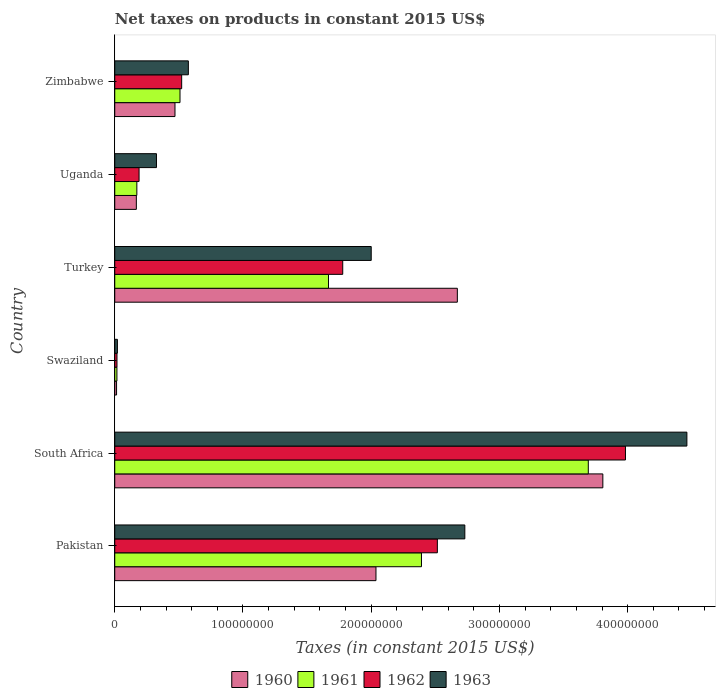How many bars are there on the 2nd tick from the bottom?
Provide a short and direct response. 4. What is the label of the 2nd group of bars from the top?
Provide a succinct answer. Uganda. In how many cases, is the number of bars for a given country not equal to the number of legend labels?
Give a very brief answer. 0. Across all countries, what is the maximum net taxes on products in 1962?
Your response must be concise. 3.98e+08. Across all countries, what is the minimum net taxes on products in 1962?
Offer a very short reply. 1.73e+06. In which country was the net taxes on products in 1960 maximum?
Your answer should be compact. South Africa. In which country was the net taxes on products in 1961 minimum?
Offer a very short reply. Swaziland. What is the total net taxes on products in 1962 in the graph?
Your answer should be very brief. 9.00e+08. What is the difference between the net taxes on products in 1963 in Uganda and that in Zimbabwe?
Your response must be concise. -2.49e+07. What is the difference between the net taxes on products in 1960 in Uganda and the net taxes on products in 1963 in Pakistan?
Your answer should be very brief. -2.56e+08. What is the average net taxes on products in 1963 per country?
Keep it short and to the point. 1.69e+08. What is the difference between the net taxes on products in 1960 and net taxes on products in 1962 in Pakistan?
Provide a succinct answer. -4.79e+07. What is the ratio of the net taxes on products in 1962 in Turkey to that in Zimbabwe?
Give a very brief answer. 3.41. What is the difference between the highest and the second highest net taxes on products in 1963?
Give a very brief answer. 1.73e+08. What is the difference between the highest and the lowest net taxes on products in 1962?
Provide a short and direct response. 3.97e+08. In how many countries, is the net taxes on products in 1962 greater than the average net taxes on products in 1962 taken over all countries?
Keep it short and to the point. 3. Is it the case that in every country, the sum of the net taxes on products in 1960 and net taxes on products in 1963 is greater than the net taxes on products in 1961?
Give a very brief answer. Yes. How many bars are there?
Your response must be concise. 24. How many countries are there in the graph?
Give a very brief answer. 6. What is the difference between two consecutive major ticks on the X-axis?
Ensure brevity in your answer.  1.00e+08. Does the graph contain any zero values?
Offer a terse response. No. Does the graph contain grids?
Give a very brief answer. No. Where does the legend appear in the graph?
Your response must be concise. Bottom center. How many legend labels are there?
Your answer should be very brief. 4. What is the title of the graph?
Your answer should be compact. Net taxes on products in constant 2015 US$. Does "2011" appear as one of the legend labels in the graph?
Make the answer very short. No. What is the label or title of the X-axis?
Keep it short and to the point. Taxes (in constant 2015 US$). What is the label or title of the Y-axis?
Give a very brief answer. Country. What is the Taxes (in constant 2015 US$) in 1960 in Pakistan?
Your response must be concise. 2.04e+08. What is the Taxes (in constant 2015 US$) of 1961 in Pakistan?
Ensure brevity in your answer.  2.39e+08. What is the Taxes (in constant 2015 US$) of 1962 in Pakistan?
Offer a very short reply. 2.52e+08. What is the Taxes (in constant 2015 US$) of 1963 in Pakistan?
Provide a short and direct response. 2.73e+08. What is the Taxes (in constant 2015 US$) of 1960 in South Africa?
Your response must be concise. 3.81e+08. What is the Taxes (in constant 2015 US$) of 1961 in South Africa?
Make the answer very short. 3.69e+08. What is the Taxes (in constant 2015 US$) of 1962 in South Africa?
Give a very brief answer. 3.98e+08. What is the Taxes (in constant 2015 US$) in 1963 in South Africa?
Give a very brief answer. 4.46e+08. What is the Taxes (in constant 2015 US$) in 1960 in Swaziland?
Make the answer very short. 1.40e+06. What is the Taxes (in constant 2015 US$) in 1961 in Swaziland?
Provide a short and direct response. 1.69e+06. What is the Taxes (in constant 2015 US$) of 1962 in Swaziland?
Provide a succinct answer. 1.73e+06. What is the Taxes (in constant 2015 US$) in 1963 in Swaziland?
Give a very brief answer. 2.06e+06. What is the Taxes (in constant 2015 US$) in 1960 in Turkey?
Your answer should be very brief. 2.67e+08. What is the Taxes (in constant 2015 US$) in 1961 in Turkey?
Offer a very short reply. 1.67e+08. What is the Taxes (in constant 2015 US$) in 1962 in Turkey?
Provide a succinct answer. 1.78e+08. What is the Taxes (in constant 2015 US$) in 1963 in Turkey?
Provide a succinct answer. 2.00e+08. What is the Taxes (in constant 2015 US$) of 1960 in Uganda?
Give a very brief answer. 1.68e+07. What is the Taxes (in constant 2015 US$) of 1961 in Uganda?
Your response must be concise. 1.72e+07. What is the Taxes (in constant 2015 US$) of 1962 in Uganda?
Keep it short and to the point. 1.90e+07. What is the Taxes (in constant 2015 US$) in 1963 in Uganda?
Give a very brief answer. 3.25e+07. What is the Taxes (in constant 2015 US$) of 1960 in Zimbabwe?
Your response must be concise. 4.70e+07. What is the Taxes (in constant 2015 US$) in 1961 in Zimbabwe?
Your answer should be very brief. 5.09e+07. What is the Taxes (in constant 2015 US$) of 1962 in Zimbabwe?
Your answer should be compact. 5.22e+07. What is the Taxes (in constant 2015 US$) of 1963 in Zimbabwe?
Your response must be concise. 5.74e+07. Across all countries, what is the maximum Taxes (in constant 2015 US$) in 1960?
Your response must be concise. 3.81e+08. Across all countries, what is the maximum Taxes (in constant 2015 US$) of 1961?
Provide a short and direct response. 3.69e+08. Across all countries, what is the maximum Taxes (in constant 2015 US$) in 1962?
Your response must be concise. 3.98e+08. Across all countries, what is the maximum Taxes (in constant 2015 US$) of 1963?
Ensure brevity in your answer.  4.46e+08. Across all countries, what is the minimum Taxes (in constant 2015 US$) of 1960?
Make the answer very short. 1.40e+06. Across all countries, what is the minimum Taxes (in constant 2015 US$) in 1961?
Offer a terse response. 1.69e+06. Across all countries, what is the minimum Taxes (in constant 2015 US$) in 1962?
Provide a short and direct response. 1.73e+06. Across all countries, what is the minimum Taxes (in constant 2015 US$) of 1963?
Offer a very short reply. 2.06e+06. What is the total Taxes (in constant 2015 US$) in 1960 in the graph?
Give a very brief answer. 9.17e+08. What is the total Taxes (in constant 2015 US$) in 1961 in the graph?
Make the answer very short. 8.45e+08. What is the total Taxes (in constant 2015 US$) in 1962 in the graph?
Offer a very short reply. 9.00e+08. What is the total Taxes (in constant 2015 US$) in 1963 in the graph?
Offer a very short reply. 1.01e+09. What is the difference between the Taxes (in constant 2015 US$) of 1960 in Pakistan and that in South Africa?
Provide a short and direct response. -1.77e+08. What is the difference between the Taxes (in constant 2015 US$) of 1961 in Pakistan and that in South Africa?
Provide a succinct answer. -1.30e+08. What is the difference between the Taxes (in constant 2015 US$) in 1962 in Pakistan and that in South Africa?
Your answer should be compact. -1.47e+08. What is the difference between the Taxes (in constant 2015 US$) of 1963 in Pakistan and that in South Africa?
Keep it short and to the point. -1.73e+08. What is the difference between the Taxes (in constant 2015 US$) in 1960 in Pakistan and that in Swaziland?
Your response must be concise. 2.02e+08. What is the difference between the Taxes (in constant 2015 US$) of 1961 in Pakistan and that in Swaziland?
Offer a terse response. 2.37e+08. What is the difference between the Taxes (in constant 2015 US$) of 1962 in Pakistan and that in Swaziland?
Ensure brevity in your answer.  2.50e+08. What is the difference between the Taxes (in constant 2015 US$) in 1963 in Pakistan and that in Swaziland?
Your answer should be compact. 2.71e+08. What is the difference between the Taxes (in constant 2015 US$) in 1960 in Pakistan and that in Turkey?
Offer a terse response. -6.35e+07. What is the difference between the Taxes (in constant 2015 US$) in 1961 in Pakistan and that in Turkey?
Your answer should be very brief. 7.25e+07. What is the difference between the Taxes (in constant 2015 US$) of 1962 in Pakistan and that in Turkey?
Give a very brief answer. 7.38e+07. What is the difference between the Taxes (in constant 2015 US$) of 1963 in Pakistan and that in Turkey?
Make the answer very short. 7.30e+07. What is the difference between the Taxes (in constant 2015 US$) of 1960 in Pakistan and that in Uganda?
Offer a very short reply. 1.87e+08. What is the difference between the Taxes (in constant 2015 US$) of 1961 in Pakistan and that in Uganda?
Keep it short and to the point. 2.22e+08. What is the difference between the Taxes (in constant 2015 US$) in 1962 in Pakistan and that in Uganda?
Your response must be concise. 2.33e+08. What is the difference between the Taxes (in constant 2015 US$) of 1963 in Pakistan and that in Uganda?
Provide a short and direct response. 2.40e+08. What is the difference between the Taxes (in constant 2015 US$) in 1960 in Pakistan and that in Zimbabwe?
Offer a terse response. 1.57e+08. What is the difference between the Taxes (in constant 2015 US$) in 1961 in Pakistan and that in Zimbabwe?
Provide a succinct answer. 1.88e+08. What is the difference between the Taxes (in constant 2015 US$) of 1962 in Pakistan and that in Zimbabwe?
Ensure brevity in your answer.  1.99e+08. What is the difference between the Taxes (in constant 2015 US$) of 1963 in Pakistan and that in Zimbabwe?
Your response must be concise. 2.16e+08. What is the difference between the Taxes (in constant 2015 US$) of 1960 in South Africa and that in Swaziland?
Give a very brief answer. 3.79e+08. What is the difference between the Taxes (in constant 2015 US$) in 1961 in South Africa and that in Swaziland?
Provide a succinct answer. 3.68e+08. What is the difference between the Taxes (in constant 2015 US$) of 1962 in South Africa and that in Swaziland?
Offer a very short reply. 3.97e+08. What is the difference between the Taxes (in constant 2015 US$) of 1963 in South Africa and that in Swaziland?
Your answer should be compact. 4.44e+08. What is the difference between the Taxes (in constant 2015 US$) in 1960 in South Africa and that in Turkey?
Offer a terse response. 1.13e+08. What is the difference between the Taxes (in constant 2015 US$) of 1961 in South Africa and that in Turkey?
Offer a terse response. 2.03e+08. What is the difference between the Taxes (in constant 2015 US$) of 1962 in South Africa and that in Turkey?
Offer a terse response. 2.20e+08. What is the difference between the Taxes (in constant 2015 US$) in 1963 in South Africa and that in Turkey?
Your answer should be compact. 2.46e+08. What is the difference between the Taxes (in constant 2015 US$) in 1960 in South Africa and that in Uganda?
Make the answer very short. 3.64e+08. What is the difference between the Taxes (in constant 2015 US$) of 1961 in South Africa and that in Uganda?
Give a very brief answer. 3.52e+08. What is the difference between the Taxes (in constant 2015 US$) of 1962 in South Africa and that in Uganda?
Provide a short and direct response. 3.79e+08. What is the difference between the Taxes (in constant 2015 US$) of 1963 in South Africa and that in Uganda?
Make the answer very short. 4.14e+08. What is the difference between the Taxes (in constant 2015 US$) of 1960 in South Africa and that in Zimbabwe?
Your response must be concise. 3.34e+08. What is the difference between the Taxes (in constant 2015 US$) of 1961 in South Africa and that in Zimbabwe?
Provide a short and direct response. 3.18e+08. What is the difference between the Taxes (in constant 2015 US$) in 1962 in South Africa and that in Zimbabwe?
Your answer should be very brief. 3.46e+08. What is the difference between the Taxes (in constant 2015 US$) of 1963 in South Africa and that in Zimbabwe?
Your response must be concise. 3.89e+08. What is the difference between the Taxes (in constant 2015 US$) in 1960 in Swaziland and that in Turkey?
Your answer should be compact. -2.66e+08. What is the difference between the Taxes (in constant 2015 US$) of 1961 in Swaziland and that in Turkey?
Provide a succinct answer. -1.65e+08. What is the difference between the Taxes (in constant 2015 US$) of 1962 in Swaziland and that in Turkey?
Your answer should be compact. -1.76e+08. What is the difference between the Taxes (in constant 2015 US$) in 1963 in Swaziland and that in Turkey?
Ensure brevity in your answer.  -1.98e+08. What is the difference between the Taxes (in constant 2015 US$) of 1960 in Swaziland and that in Uganda?
Your answer should be compact. -1.54e+07. What is the difference between the Taxes (in constant 2015 US$) of 1961 in Swaziland and that in Uganda?
Make the answer very short. -1.55e+07. What is the difference between the Taxes (in constant 2015 US$) in 1962 in Swaziland and that in Uganda?
Provide a short and direct response. -1.72e+07. What is the difference between the Taxes (in constant 2015 US$) of 1963 in Swaziland and that in Uganda?
Give a very brief answer. -3.05e+07. What is the difference between the Taxes (in constant 2015 US$) of 1960 in Swaziland and that in Zimbabwe?
Make the answer very short. -4.56e+07. What is the difference between the Taxes (in constant 2015 US$) in 1961 in Swaziland and that in Zimbabwe?
Your answer should be very brief. -4.92e+07. What is the difference between the Taxes (in constant 2015 US$) in 1962 in Swaziland and that in Zimbabwe?
Provide a short and direct response. -5.05e+07. What is the difference between the Taxes (in constant 2015 US$) in 1963 in Swaziland and that in Zimbabwe?
Keep it short and to the point. -5.53e+07. What is the difference between the Taxes (in constant 2015 US$) of 1960 in Turkey and that in Uganda?
Ensure brevity in your answer.  2.50e+08. What is the difference between the Taxes (in constant 2015 US$) in 1961 in Turkey and that in Uganda?
Make the answer very short. 1.49e+08. What is the difference between the Taxes (in constant 2015 US$) in 1962 in Turkey and that in Uganda?
Keep it short and to the point. 1.59e+08. What is the difference between the Taxes (in constant 2015 US$) of 1963 in Turkey and that in Uganda?
Give a very brief answer. 1.67e+08. What is the difference between the Taxes (in constant 2015 US$) in 1960 in Turkey and that in Zimbabwe?
Offer a very short reply. 2.20e+08. What is the difference between the Taxes (in constant 2015 US$) of 1961 in Turkey and that in Zimbabwe?
Provide a succinct answer. 1.16e+08. What is the difference between the Taxes (in constant 2015 US$) of 1962 in Turkey and that in Zimbabwe?
Give a very brief answer. 1.26e+08. What is the difference between the Taxes (in constant 2015 US$) of 1963 in Turkey and that in Zimbabwe?
Give a very brief answer. 1.43e+08. What is the difference between the Taxes (in constant 2015 US$) of 1960 in Uganda and that in Zimbabwe?
Ensure brevity in your answer.  -3.01e+07. What is the difference between the Taxes (in constant 2015 US$) in 1961 in Uganda and that in Zimbabwe?
Your answer should be very brief. -3.37e+07. What is the difference between the Taxes (in constant 2015 US$) in 1962 in Uganda and that in Zimbabwe?
Provide a short and direct response. -3.32e+07. What is the difference between the Taxes (in constant 2015 US$) in 1963 in Uganda and that in Zimbabwe?
Your response must be concise. -2.49e+07. What is the difference between the Taxes (in constant 2015 US$) in 1960 in Pakistan and the Taxes (in constant 2015 US$) in 1961 in South Africa?
Ensure brevity in your answer.  -1.66e+08. What is the difference between the Taxes (in constant 2015 US$) of 1960 in Pakistan and the Taxes (in constant 2015 US$) of 1962 in South Africa?
Ensure brevity in your answer.  -1.95e+08. What is the difference between the Taxes (in constant 2015 US$) of 1960 in Pakistan and the Taxes (in constant 2015 US$) of 1963 in South Africa?
Provide a short and direct response. -2.42e+08. What is the difference between the Taxes (in constant 2015 US$) of 1961 in Pakistan and the Taxes (in constant 2015 US$) of 1962 in South Africa?
Your answer should be very brief. -1.59e+08. What is the difference between the Taxes (in constant 2015 US$) in 1961 in Pakistan and the Taxes (in constant 2015 US$) in 1963 in South Africa?
Your answer should be very brief. -2.07e+08. What is the difference between the Taxes (in constant 2015 US$) in 1962 in Pakistan and the Taxes (in constant 2015 US$) in 1963 in South Africa?
Provide a short and direct response. -1.95e+08. What is the difference between the Taxes (in constant 2015 US$) in 1960 in Pakistan and the Taxes (in constant 2015 US$) in 1961 in Swaziland?
Provide a succinct answer. 2.02e+08. What is the difference between the Taxes (in constant 2015 US$) in 1960 in Pakistan and the Taxes (in constant 2015 US$) in 1962 in Swaziland?
Your answer should be very brief. 2.02e+08. What is the difference between the Taxes (in constant 2015 US$) of 1960 in Pakistan and the Taxes (in constant 2015 US$) of 1963 in Swaziland?
Your response must be concise. 2.02e+08. What is the difference between the Taxes (in constant 2015 US$) of 1961 in Pakistan and the Taxes (in constant 2015 US$) of 1962 in Swaziland?
Keep it short and to the point. 2.37e+08. What is the difference between the Taxes (in constant 2015 US$) in 1961 in Pakistan and the Taxes (in constant 2015 US$) in 1963 in Swaziland?
Ensure brevity in your answer.  2.37e+08. What is the difference between the Taxes (in constant 2015 US$) in 1962 in Pakistan and the Taxes (in constant 2015 US$) in 1963 in Swaziland?
Provide a succinct answer. 2.50e+08. What is the difference between the Taxes (in constant 2015 US$) in 1960 in Pakistan and the Taxes (in constant 2015 US$) in 1961 in Turkey?
Provide a short and direct response. 3.70e+07. What is the difference between the Taxes (in constant 2015 US$) in 1960 in Pakistan and the Taxes (in constant 2015 US$) in 1962 in Turkey?
Your answer should be very brief. 2.59e+07. What is the difference between the Taxes (in constant 2015 US$) in 1960 in Pakistan and the Taxes (in constant 2015 US$) in 1963 in Turkey?
Offer a terse response. 3.70e+06. What is the difference between the Taxes (in constant 2015 US$) in 1961 in Pakistan and the Taxes (in constant 2015 US$) in 1962 in Turkey?
Your answer should be very brief. 6.14e+07. What is the difference between the Taxes (in constant 2015 US$) in 1961 in Pakistan and the Taxes (in constant 2015 US$) in 1963 in Turkey?
Your answer should be compact. 3.92e+07. What is the difference between the Taxes (in constant 2015 US$) in 1962 in Pakistan and the Taxes (in constant 2015 US$) in 1963 in Turkey?
Your answer should be compact. 5.16e+07. What is the difference between the Taxes (in constant 2015 US$) of 1960 in Pakistan and the Taxes (in constant 2015 US$) of 1961 in Uganda?
Your answer should be compact. 1.86e+08. What is the difference between the Taxes (in constant 2015 US$) in 1960 in Pakistan and the Taxes (in constant 2015 US$) in 1962 in Uganda?
Your answer should be compact. 1.85e+08. What is the difference between the Taxes (in constant 2015 US$) of 1960 in Pakistan and the Taxes (in constant 2015 US$) of 1963 in Uganda?
Your answer should be very brief. 1.71e+08. What is the difference between the Taxes (in constant 2015 US$) in 1961 in Pakistan and the Taxes (in constant 2015 US$) in 1962 in Uganda?
Offer a very short reply. 2.20e+08. What is the difference between the Taxes (in constant 2015 US$) of 1961 in Pakistan and the Taxes (in constant 2015 US$) of 1963 in Uganda?
Provide a succinct answer. 2.07e+08. What is the difference between the Taxes (in constant 2015 US$) in 1962 in Pakistan and the Taxes (in constant 2015 US$) in 1963 in Uganda?
Offer a terse response. 2.19e+08. What is the difference between the Taxes (in constant 2015 US$) in 1960 in Pakistan and the Taxes (in constant 2015 US$) in 1961 in Zimbabwe?
Ensure brevity in your answer.  1.53e+08. What is the difference between the Taxes (in constant 2015 US$) in 1960 in Pakistan and the Taxes (in constant 2015 US$) in 1962 in Zimbabwe?
Make the answer very short. 1.52e+08. What is the difference between the Taxes (in constant 2015 US$) of 1960 in Pakistan and the Taxes (in constant 2015 US$) of 1963 in Zimbabwe?
Keep it short and to the point. 1.46e+08. What is the difference between the Taxes (in constant 2015 US$) in 1961 in Pakistan and the Taxes (in constant 2015 US$) in 1962 in Zimbabwe?
Make the answer very short. 1.87e+08. What is the difference between the Taxes (in constant 2015 US$) in 1961 in Pakistan and the Taxes (in constant 2015 US$) in 1963 in Zimbabwe?
Your response must be concise. 1.82e+08. What is the difference between the Taxes (in constant 2015 US$) of 1962 in Pakistan and the Taxes (in constant 2015 US$) of 1963 in Zimbabwe?
Your answer should be compact. 1.94e+08. What is the difference between the Taxes (in constant 2015 US$) of 1960 in South Africa and the Taxes (in constant 2015 US$) of 1961 in Swaziland?
Give a very brief answer. 3.79e+08. What is the difference between the Taxes (in constant 2015 US$) of 1960 in South Africa and the Taxes (in constant 2015 US$) of 1962 in Swaziland?
Keep it short and to the point. 3.79e+08. What is the difference between the Taxes (in constant 2015 US$) in 1960 in South Africa and the Taxes (in constant 2015 US$) in 1963 in Swaziland?
Provide a succinct answer. 3.79e+08. What is the difference between the Taxes (in constant 2015 US$) of 1961 in South Africa and the Taxes (in constant 2015 US$) of 1962 in Swaziland?
Keep it short and to the point. 3.68e+08. What is the difference between the Taxes (in constant 2015 US$) of 1961 in South Africa and the Taxes (in constant 2015 US$) of 1963 in Swaziland?
Your answer should be very brief. 3.67e+08. What is the difference between the Taxes (in constant 2015 US$) in 1962 in South Africa and the Taxes (in constant 2015 US$) in 1963 in Swaziland?
Make the answer very short. 3.96e+08. What is the difference between the Taxes (in constant 2015 US$) of 1960 in South Africa and the Taxes (in constant 2015 US$) of 1961 in Turkey?
Your answer should be very brief. 2.14e+08. What is the difference between the Taxes (in constant 2015 US$) of 1960 in South Africa and the Taxes (in constant 2015 US$) of 1962 in Turkey?
Give a very brief answer. 2.03e+08. What is the difference between the Taxes (in constant 2015 US$) in 1960 in South Africa and the Taxes (in constant 2015 US$) in 1963 in Turkey?
Give a very brief answer. 1.81e+08. What is the difference between the Taxes (in constant 2015 US$) in 1961 in South Africa and the Taxes (in constant 2015 US$) in 1962 in Turkey?
Your answer should be compact. 1.91e+08. What is the difference between the Taxes (in constant 2015 US$) of 1961 in South Africa and the Taxes (in constant 2015 US$) of 1963 in Turkey?
Ensure brevity in your answer.  1.69e+08. What is the difference between the Taxes (in constant 2015 US$) in 1962 in South Africa and the Taxes (in constant 2015 US$) in 1963 in Turkey?
Your answer should be compact. 1.98e+08. What is the difference between the Taxes (in constant 2015 US$) in 1960 in South Africa and the Taxes (in constant 2015 US$) in 1961 in Uganda?
Your answer should be very brief. 3.63e+08. What is the difference between the Taxes (in constant 2015 US$) of 1960 in South Africa and the Taxes (in constant 2015 US$) of 1962 in Uganda?
Give a very brief answer. 3.62e+08. What is the difference between the Taxes (in constant 2015 US$) in 1960 in South Africa and the Taxes (in constant 2015 US$) in 1963 in Uganda?
Offer a very short reply. 3.48e+08. What is the difference between the Taxes (in constant 2015 US$) of 1961 in South Africa and the Taxes (in constant 2015 US$) of 1962 in Uganda?
Provide a short and direct response. 3.50e+08. What is the difference between the Taxes (in constant 2015 US$) of 1961 in South Africa and the Taxes (in constant 2015 US$) of 1963 in Uganda?
Keep it short and to the point. 3.37e+08. What is the difference between the Taxes (in constant 2015 US$) of 1962 in South Africa and the Taxes (in constant 2015 US$) of 1963 in Uganda?
Make the answer very short. 3.66e+08. What is the difference between the Taxes (in constant 2015 US$) in 1960 in South Africa and the Taxes (in constant 2015 US$) in 1961 in Zimbabwe?
Your response must be concise. 3.30e+08. What is the difference between the Taxes (in constant 2015 US$) of 1960 in South Africa and the Taxes (in constant 2015 US$) of 1962 in Zimbabwe?
Make the answer very short. 3.28e+08. What is the difference between the Taxes (in constant 2015 US$) in 1960 in South Africa and the Taxes (in constant 2015 US$) in 1963 in Zimbabwe?
Keep it short and to the point. 3.23e+08. What is the difference between the Taxes (in constant 2015 US$) in 1961 in South Africa and the Taxes (in constant 2015 US$) in 1962 in Zimbabwe?
Give a very brief answer. 3.17e+08. What is the difference between the Taxes (in constant 2015 US$) of 1961 in South Africa and the Taxes (in constant 2015 US$) of 1963 in Zimbabwe?
Give a very brief answer. 3.12e+08. What is the difference between the Taxes (in constant 2015 US$) in 1962 in South Africa and the Taxes (in constant 2015 US$) in 1963 in Zimbabwe?
Ensure brevity in your answer.  3.41e+08. What is the difference between the Taxes (in constant 2015 US$) of 1960 in Swaziland and the Taxes (in constant 2015 US$) of 1961 in Turkey?
Your answer should be very brief. -1.65e+08. What is the difference between the Taxes (in constant 2015 US$) of 1960 in Swaziland and the Taxes (in constant 2015 US$) of 1962 in Turkey?
Offer a very short reply. -1.76e+08. What is the difference between the Taxes (in constant 2015 US$) in 1960 in Swaziland and the Taxes (in constant 2015 US$) in 1963 in Turkey?
Offer a terse response. -1.99e+08. What is the difference between the Taxes (in constant 2015 US$) of 1961 in Swaziland and the Taxes (in constant 2015 US$) of 1962 in Turkey?
Keep it short and to the point. -1.76e+08. What is the difference between the Taxes (in constant 2015 US$) of 1961 in Swaziland and the Taxes (in constant 2015 US$) of 1963 in Turkey?
Your answer should be very brief. -1.98e+08. What is the difference between the Taxes (in constant 2015 US$) of 1962 in Swaziland and the Taxes (in constant 2015 US$) of 1963 in Turkey?
Give a very brief answer. -1.98e+08. What is the difference between the Taxes (in constant 2015 US$) of 1960 in Swaziland and the Taxes (in constant 2015 US$) of 1961 in Uganda?
Your answer should be very brief. -1.58e+07. What is the difference between the Taxes (in constant 2015 US$) in 1960 in Swaziland and the Taxes (in constant 2015 US$) in 1962 in Uganda?
Keep it short and to the point. -1.76e+07. What is the difference between the Taxes (in constant 2015 US$) in 1960 in Swaziland and the Taxes (in constant 2015 US$) in 1963 in Uganda?
Your answer should be compact. -3.11e+07. What is the difference between the Taxes (in constant 2015 US$) in 1961 in Swaziland and the Taxes (in constant 2015 US$) in 1962 in Uganda?
Give a very brief answer. -1.73e+07. What is the difference between the Taxes (in constant 2015 US$) in 1961 in Swaziland and the Taxes (in constant 2015 US$) in 1963 in Uganda?
Provide a short and direct response. -3.08e+07. What is the difference between the Taxes (in constant 2015 US$) in 1962 in Swaziland and the Taxes (in constant 2015 US$) in 1963 in Uganda?
Provide a succinct answer. -3.08e+07. What is the difference between the Taxes (in constant 2015 US$) in 1960 in Swaziland and the Taxes (in constant 2015 US$) in 1961 in Zimbabwe?
Offer a terse response. -4.95e+07. What is the difference between the Taxes (in constant 2015 US$) in 1960 in Swaziland and the Taxes (in constant 2015 US$) in 1962 in Zimbabwe?
Make the answer very short. -5.08e+07. What is the difference between the Taxes (in constant 2015 US$) of 1960 in Swaziland and the Taxes (in constant 2015 US$) of 1963 in Zimbabwe?
Ensure brevity in your answer.  -5.60e+07. What is the difference between the Taxes (in constant 2015 US$) of 1961 in Swaziland and the Taxes (in constant 2015 US$) of 1962 in Zimbabwe?
Make the answer very short. -5.05e+07. What is the difference between the Taxes (in constant 2015 US$) of 1961 in Swaziland and the Taxes (in constant 2015 US$) of 1963 in Zimbabwe?
Make the answer very short. -5.57e+07. What is the difference between the Taxes (in constant 2015 US$) in 1962 in Swaziland and the Taxes (in constant 2015 US$) in 1963 in Zimbabwe?
Offer a terse response. -5.57e+07. What is the difference between the Taxes (in constant 2015 US$) in 1960 in Turkey and the Taxes (in constant 2015 US$) in 1961 in Uganda?
Make the answer very short. 2.50e+08. What is the difference between the Taxes (in constant 2015 US$) of 1960 in Turkey and the Taxes (in constant 2015 US$) of 1962 in Uganda?
Make the answer very short. 2.48e+08. What is the difference between the Taxes (in constant 2015 US$) of 1960 in Turkey and the Taxes (in constant 2015 US$) of 1963 in Uganda?
Provide a short and direct response. 2.35e+08. What is the difference between the Taxes (in constant 2015 US$) of 1961 in Turkey and the Taxes (in constant 2015 US$) of 1962 in Uganda?
Your answer should be very brief. 1.48e+08. What is the difference between the Taxes (in constant 2015 US$) of 1961 in Turkey and the Taxes (in constant 2015 US$) of 1963 in Uganda?
Keep it short and to the point. 1.34e+08. What is the difference between the Taxes (in constant 2015 US$) in 1962 in Turkey and the Taxes (in constant 2015 US$) in 1963 in Uganda?
Keep it short and to the point. 1.45e+08. What is the difference between the Taxes (in constant 2015 US$) of 1960 in Turkey and the Taxes (in constant 2015 US$) of 1961 in Zimbabwe?
Offer a terse response. 2.16e+08. What is the difference between the Taxes (in constant 2015 US$) in 1960 in Turkey and the Taxes (in constant 2015 US$) in 1962 in Zimbabwe?
Offer a terse response. 2.15e+08. What is the difference between the Taxes (in constant 2015 US$) in 1960 in Turkey and the Taxes (in constant 2015 US$) in 1963 in Zimbabwe?
Provide a short and direct response. 2.10e+08. What is the difference between the Taxes (in constant 2015 US$) of 1961 in Turkey and the Taxes (in constant 2015 US$) of 1962 in Zimbabwe?
Provide a short and direct response. 1.14e+08. What is the difference between the Taxes (in constant 2015 US$) of 1961 in Turkey and the Taxes (in constant 2015 US$) of 1963 in Zimbabwe?
Offer a very short reply. 1.09e+08. What is the difference between the Taxes (in constant 2015 US$) of 1962 in Turkey and the Taxes (in constant 2015 US$) of 1963 in Zimbabwe?
Your answer should be compact. 1.20e+08. What is the difference between the Taxes (in constant 2015 US$) of 1960 in Uganda and the Taxes (in constant 2015 US$) of 1961 in Zimbabwe?
Your answer should be very brief. -3.40e+07. What is the difference between the Taxes (in constant 2015 US$) in 1960 in Uganda and the Taxes (in constant 2015 US$) in 1962 in Zimbabwe?
Provide a short and direct response. -3.53e+07. What is the difference between the Taxes (in constant 2015 US$) in 1960 in Uganda and the Taxes (in constant 2015 US$) in 1963 in Zimbabwe?
Give a very brief answer. -4.06e+07. What is the difference between the Taxes (in constant 2015 US$) in 1961 in Uganda and the Taxes (in constant 2015 US$) in 1962 in Zimbabwe?
Give a very brief answer. -3.50e+07. What is the difference between the Taxes (in constant 2015 US$) in 1961 in Uganda and the Taxes (in constant 2015 US$) in 1963 in Zimbabwe?
Provide a short and direct response. -4.02e+07. What is the difference between the Taxes (in constant 2015 US$) in 1962 in Uganda and the Taxes (in constant 2015 US$) in 1963 in Zimbabwe?
Your response must be concise. -3.84e+07. What is the average Taxes (in constant 2015 US$) of 1960 per country?
Provide a short and direct response. 1.53e+08. What is the average Taxes (in constant 2015 US$) of 1961 per country?
Keep it short and to the point. 1.41e+08. What is the average Taxes (in constant 2015 US$) in 1962 per country?
Provide a short and direct response. 1.50e+08. What is the average Taxes (in constant 2015 US$) of 1963 per country?
Provide a short and direct response. 1.69e+08. What is the difference between the Taxes (in constant 2015 US$) in 1960 and Taxes (in constant 2015 US$) in 1961 in Pakistan?
Ensure brevity in your answer.  -3.55e+07. What is the difference between the Taxes (in constant 2015 US$) of 1960 and Taxes (in constant 2015 US$) of 1962 in Pakistan?
Make the answer very short. -4.79e+07. What is the difference between the Taxes (in constant 2015 US$) of 1960 and Taxes (in constant 2015 US$) of 1963 in Pakistan?
Provide a succinct answer. -6.93e+07. What is the difference between the Taxes (in constant 2015 US$) of 1961 and Taxes (in constant 2015 US$) of 1962 in Pakistan?
Make the answer very short. -1.24e+07. What is the difference between the Taxes (in constant 2015 US$) of 1961 and Taxes (in constant 2015 US$) of 1963 in Pakistan?
Offer a very short reply. -3.38e+07. What is the difference between the Taxes (in constant 2015 US$) in 1962 and Taxes (in constant 2015 US$) in 1963 in Pakistan?
Keep it short and to the point. -2.14e+07. What is the difference between the Taxes (in constant 2015 US$) in 1960 and Taxes (in constant 2015 US$) in 1961 in South Africa?
Offer a very short reply. 1.13e+07. What is the difference between the Taxes (in constant 2015 US$) in 1960 and Taxes (in constant 2015 US$) in 1962 in South Africa?
Provide a succinct answer. -1.76e+07. What is the difference between the Taxes (in constant 2015 US$) of 1960 and Taxes (in constant 2015 US$) of 1963 in South Africa?
Ensure brevity in your answer.  -6.55e+07. What is the difference between the Taxes (in constant 2015 US$) of 1961 and Taxes (in constant 2015 US$) of 1962 in South Africa?
Provide a short and direct response. -2.90e+07. What is the difference between the Taxes (in constant 2015 US$) in 1961 and Taxes (in constant 2015 US$) in 1963 in South Africa?
Keep it short and to the point. -7.69e+07. What is the difference between the Taxes (in constant 2015 US$) in 1962 and Taxes (in constant 2015 US$) in 1963 in South Africa?
Your answer should be very brief. -4.79e+07. What is the difference between the Taxes (in constant 2015 US$) in 1960 and Taxes (in constant 2015 US$) in 1961 in Swaziland?
Your answer should be very brief. -2.89e+05. What is the difference between the Taxes (in constant 2015 US$) in 1960 and Taxes (in constant 2015 US$) in 1962 in Swaziland?
Keep it short and to the point. -3.30e+05. What is the difference between the Taxes (in constant 2015 US$) in 1960 and Taxes (in constant 2015 US$) in 1963 in Swaziland?
Offer a terse response. -6.61e+05. What is the difference between the Taxes (in constant 2015 US$) of 1961 and Taxes (in constant 2015 US$) of 1962 in Swaziland?
Make the answer very short. -4.13e+04. What is the difference between the Taxes (in constant 2015 US$) in 1961 and Taxes (in constant 2015 US$) in 1963 in Swaziland?
Your answer should be very brief. -3.72e+05. What is the difference between the Taxes (in constant 2015 US$) of 1962 and Taxes (in constant 2015 US$) of 1963 in Swaziland?
Offer a terse response. -3.30e+05. What is the difference between the Taxes (in constant 2015 US$) in 1960 and Taxes (in constant 2015 US$) in 1961 in Turkey?
Your answer should be very brief. 1.00e+08. What is the difference between the Taxes (in constant 2015 US$) in 1960 and Taxes (in constant 2015 US$) in 1962 in Turkey?
Your answer should be very brief. 8.94e+07. What is the difference between the Taxes (in constant 2015 US$) in 1960 and Taxes (in constant 2015 US$) in 1963 in Turkey?
Your answer should be very brief. 6.72e+07. What is the difference between the Taxes (in constant 2015 US$) in 1961 and Taxes (in constant 2015 US$) in 1962 in Turkey?
Keep it short and to the point. -1.11e+07. What is the difference between the Taxes (in constant 2015 US$) in 1961 and Taxes (in constant 2015 US$) in 1963 in Turkey?
Make the answer very short. -3.33e+07. What is the difference between the Taxes (in constant 2015 US$) in 1962 and Taxes (in constant 2015 US$) in 1963 in Turkey?
Give a very brief answer. -2.22e+07. What is the difference between the Taxes (in constant 2015 US$) of 1960 and Taxes (in constant 2015 US$) of 1961 in Uganda?
Make the answer very short. -3.85e+05. What is the difference between the Taxes (in constant 2015 US$) in 1960 and Taxes (in constant 2015 US$) in 1962 in Uganda?
Your answer should be compact. -2.12e+06. What is the difference between the Taxes (in constant 2015 US$) in 1960 and Taxes (in constant 2015 US$) in 1963 in Uganda?
Make the answer very short. -1.57e+07. What is the difference between the Taxes (in constant 2015 US$) in 1961 and Taxes (in constant 2015 US$) in 1962 in Uganda?
Offer a terse response. -1.73e+06. What is the difference between the Taxes (in constant 2015 US$) in 1961 and Taxes (in constant 2015 US$) in 1963 in Uganda?
Your answer should be compact. -1.53e+07. What is the difference between the Taxes (in constant 2015 US$) of 1962 and Taxes (in constant 2015 US$) of 1963 in Uganda?
Provide a succinct answer. -1.36e+07. What is the difference between the Taxes (in constant 2015 US$) in 1960 and Taxes (in constant 2015 US$) in 1961 in Zimbabwe?
Provide a succinct answer. -3.91e+06. What is the difference between the Taxes (in constant 2015 US$) of 1960 and Taxes (in constant 2015 US$) of 1962 in Zimbabwe?
Make the answer very short. -5.22e+06. What is the difference between the Taxes (in constant 2015 US$) in 1960 and Taxes (in constant 2015 US$) in 1963 in Zimbabwe?
Keep it short and to the point. -1.04e+07. What is the difference between the Taxes (in constant 2015 US$) in 1961 and Taxes (in constant 2015 US$) in 1962 in Zimbabwe?
Ensure brevity in your answer.  -1.30e+06. What is the difference between the Taxes (in constant 2015 US$) in 1961 and Taxes (in constant 2015 US$) in 1963 in Zimbabwe?
Offer a terse response. -6.52e+06. What is the difference between the Taxes (in constant 2015 US$) in 1962 and Taxes (in constant 2015 US$) in 1963 in Zimbabwe?
Offer a terse response. -5.22e+06. What is the ratio of the Taxes (in constant 2015 US$) of 1960 in Pakistan to that in South Africa?
Your answer should be very brief. 0.54. What is the ratio of the Taxes (in constant 2015 US$) of 1961 in Pakistan to that in South Africa?
Offer a very short reply. 0.65. What is the ratio of the Taxes (in constant 2015 US$) in 1962 in Pakistan to that in South Africa?
Offer a very short reply. 0.63. What is the ratio of the Taxes (in constant 2015 US$) in 1963 in Pakistan to that in South Africa?
Offer a terse response. 0.61. What is the ratio of the Taxes (in constant 2015 US$) in 1960 in Pakistan to that in Swaziland?
Provide a short and direct response. 145.12. What is the ratio of the Taxes (in constant 2015 US$) of 1961 in Pakistan to that in Swaziland?
Your answer should be very brief. 141.31. What is the ratio of the Taxes (in constant 2015 US$) in 1962 in Pakistan to that in Swaziland?
Offer a very short reply. 145.09. What is the ratio of the Taxes (in constant 2015 US$) of 1963 in Pakistan to that in Swaziland?
Ensure brevity in your answer.  132.25. What is the ratio of the Taxes (in constant 2015 US$) in 1960 in Pakistan to that in Turkey?
Your answer should be compact. 0.76. What is the ratio of the Taxes (in constant 2015 US$) in 1961 in Pakistan to that in Turkey?
Your response must be concise. 1.44. What is the ratio of the Taxes (in constant 2015 US$) of 1962 in Pakistan to that in Turkey?
Offer a very short reply. 1.42. What is the ratio of the Taxes (in constant 2015 US$) in 1963 in Pakistan to that in Turkey?
Your response must be concise. 1.36. What is the ratio of the Taxes (in constant 2015 US$) in 1960 in Pakistan to that in Uganda?
Give a very brief answer. 12.1. What is the ratio of the Taxes (in constant 2015 US$) in 1961 in Pakistan to that in Uganda?
Make the answer very short. 13.89. What is the ratio of the Taxes (in constant 2015 US$) in 1962 in Pakistan to that in Uganda?
Offer a very short reply. 13.27. What is the ratio of the Taxes (in constant 2015 US$) of 1963 in Pakistan to that in Uganda?
Your answer should be compact. 8.39. What is the ratio of the Taxes (in constant 2015 US$) of 1960 in Pakistan to that in Zimbabwe?
Make the answer very short. 4.34. What is the ratio of the Taxes (in constant 2015 US$) in 1961 in Pakistan to that in Zimbabwe?
Keep it short and to the point. 4.7. What is the ratio of the Taxes (in constant 2015 US$) in 1962 in Pakistan to that in Zimbabwe?
Ensure brevity in your answer.  4.82. What is the ratio of the Taxes (in constant 2015 US$) of 1963 in Pakistan to that in Zimbabwe?
Offer a very short reply. 4.76. What is the ratio of the Taxes (in constant 2015 US$) of 1960 in South Africa to that in Swaziland?
Make the answer very short. 271.17. What is the ratio of the Taxes (in constant 2015 US$) in 1961 in South Africa to that in Swaziland?
Give a very brief answer. 218.17. What is the ratio of the Taxes (in constant 2015 US$) in 1962 in South Africa to that in Swaziland?
Keep it short and to the point. 229.69. What is the ratio of the Taxes (in constant 2015 US$) of 1963 in South Africa to that in Swaziland?
Your answer should be very brief. 216.15. What is the ratio of the Taxes (in constant 2015 US$) in 1960 in South Africa to that in Turkey?
Make the answer very short. 1.42. What is the ratio of the Taxes (in constant 2015 US$) in 1961 in South Africa to that in Turkey?
Provide a succinct answer. 2.22. What is the ratio of the Taxes (in constant 2015 US$) in 1962 in South Africa to that in Turkey?
Provide a short and direct response. 2.24. What is the ratio of the Taxes (in constant 2015 US$) of 1963 in South Africa to that in Turkey?
Keep it short and to the point. 2.23. What is the ratio of the Taxes (in constant 2015 US$) in 1960 in South Africa to that in Uganda?
Offer a very short reply. 22.6. What is the ratio of the Taxes (in constant 2015 US$) in 1961 in South Africa to that in Uganda?
Your answer should be compact. 21.44. What is the ratio of the Taxes (in constant 2015 US$) of 1962 in South Africa to that in Uganda?
Your answer should be very brief. 21.01. What is the ratio of the Taxes (in constant 2015 US$) in 1963 in South Africa to that in Uganda?
Keep it short and to the point. 13.72. What is the ratio of the Taxes (in constant 2015 US$) in 1960 in South Africa to that in Zimbabwe?
Keep it short and to the point. 8.1. What is the ratio of the Taxes (in constant 2015 US$) in 1961 in South Africa to that in Zimbabwe?
Make the answer very short. 7.26. What is the ratio of the Taxes (in constant 2015 US$) of 1962 in South Africa to that in Zimbabwe?
Your answer should be compact. 7.63. What is the ratio of the Taxes (in constant 2015 US$) of 1963 in South Africa to that in Zimbabwe?
Provide a short and direct response. 7.77. What is the ratio of the Taxes (in constant 2015 US$) in 1960 in Swaziland to that in Turkey?
Provide a short and direct response. 0.01. What is the ratio of the Taxes (in constant 2015 US$) of 1961 in Swaziland to that in Turkey?
Give a very brief answer. 0.01. What is the ratio of the Taxes (in constant 2015 US$) in 1962 in Swaziland to that in Turkey?
Your response must be concise. 0.01. What is the ratio of the Taxes (in constant 2015 US$) of 1963 in Swaziland to that in Turkey?
Keep it short and to the point. 0.01. What is the ratio of the Taxes (in constant 2015 US$) of 1960 in Swaziland to that in Uganda?
Your answer should be very brief. 0.08. What is the ratio of the Taxes (in constant 2015 US$) of 1961 in Swaziland to that in Uganda?
Offer a very short reply. 0.1. What is the ratio of the Taxes (in constant 2015 US$) of 1962 in Swaziland to that in Uganda?
Offer a very short reply. 0.09. What is the ratio of the Taxes (in constant 2015 US$) in 1963 in Swaziland to that in Uganda?
Your answer should be very brief. 0.06. What is the ratio of the Taxes (in constant 2015 US$) in 1960 in Swaziland to that in Zimbabwe?
Provide a succinct answer. 0.03. What is the ratio of the Taxes (in constant 2015 US$) of 1961 in Swaziland to that in Zimbabwe?
Give a very brief answer. 0.03. What is the ratio of the Taxes (in constant 2015 US$) in 1962 in Swaziland to that in Zimbabwe?
Offer a terse response. 0.03. What is the ratio of the Taxes (in constant 2015 US$) in 1963 in Swaziland to that in Zimbabwe?
Offer a terse response. 0.04. What is the ratio of the Taxes (in constant 2015 US$) of 1960 in Turkey to that in Uganda?
Provide a short and direct response. 15.86. What is the ratio of the Taxes (in constant 2015 US$) of 1961 in Turkey to that in Uganda?
Offer a very short reply. 9.68. What is the ratio of the Taxes (in constant 2015 US$) in 1962 in Turkey to that in Uganda?
Offer a very short reply. 9.38. What is the ratio of the Taxes (in constant 2015 US$) in 1963 in Turkey to that in Uganda?
Offer a terse response. 6.15. What is the ratio of the Taxes (in constant 2015 US$) in 1960 in Turkey to that in Zimbabwe?
Your answer should be very brief. 5.69. What is the ratio of the Taxes (in constant 2015 US$) of 1961 in Turkey to that in Zimbabwe?
Keep it short and to the point. 3.28. What is the ratio of the Taxes (in constant 2015 US$) in 1962 in Turkey to that in Zimbabwe?
Provide a succinct answer. 3.41. What is the ratio of the Taxes (in constant 2015 US$) of 1963 in Turkey to that in Zimbabwe?
Keep it short and to the point. 3.48. What is the ratio of the Taxes (in constant 2015 US$) of 1960 in Uganda to that in Zimbabwe?
Your response must be concise. 0.36. What is the ratio of the Taxes (in constant 2015 US$) in 1961 in Uganda to that in Zimbabwe?
Provide a short and direct response. 0.34. What is the ratio of the Taxes (in constant 2015 US$) in 1962 in Uganda to that in Zimbabwe?
Offer a very short reply. 0.36. What is the ratio of the Taxes (in constant 2015 US$) in 1963 in Uganda to that in Zimbabwe?
Provide a succinct answer. 0.57. What is the difference between the highest and the second highest Taxes (in constant 2015 US$) in 1960?
Give a very brief answer. 1.13e+08. What is the difference between the highest and the second highest Taxes (in constant 2015 US$) in 1961?
Provide a succinct answer. 1.30e+08. What is the difference between the highest and the second highest Taxes (in constant 2015 US$) in 1962?
Provide a short and direct response. 1.47e+08. What is the difference between the highest and the second highest Taxes (in constant 2015 US$) of 1963?
Offer a very short reply. 1.73e+08. What is the difference between the highest and the lowest Taxes (in constant 2015 US$) in 1960?
Your response must be concise. 3.79e+08. What is the difference between the highest and the lowest Taxes (in constant 2015 US$) in 1961?
Provide a succinct answer. 3.68e+08. What is the difference between the highest and the lowest Taxes (in constant 2015 US$) in 1962?
Your answer should be very brief. 3.97e+08. What is the difference between the highest and the lowest Taxes (in constant 2015 US$) of 1963?
Provide a short and direct response. 4.44e+08. 